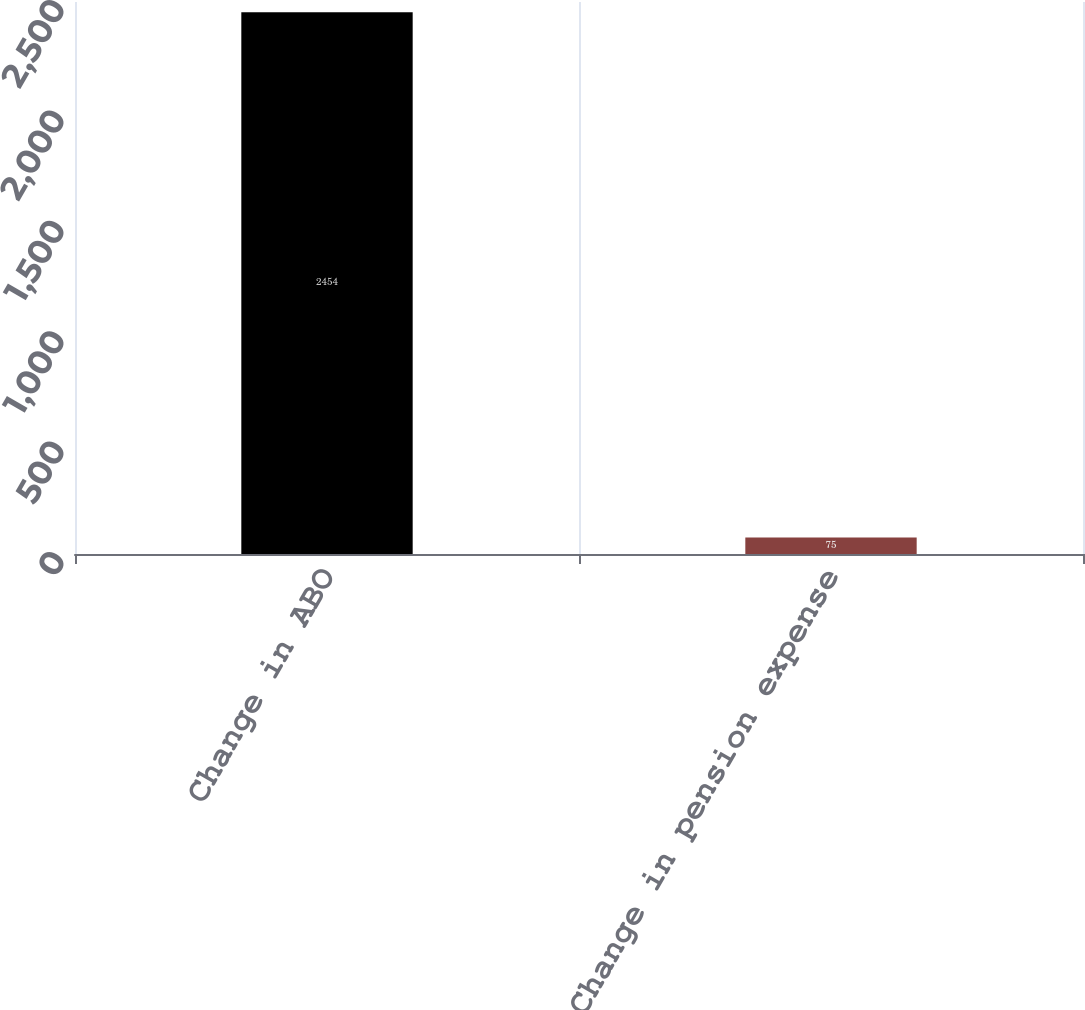Convert chart to OTSL. <chart><loc_0><loc_0><loc_500><loc_500><bar_chart><fcel>Change in ABO<fcel>Change in pension expense<nl><fcel>2454<fcel>75<nl></chart> 